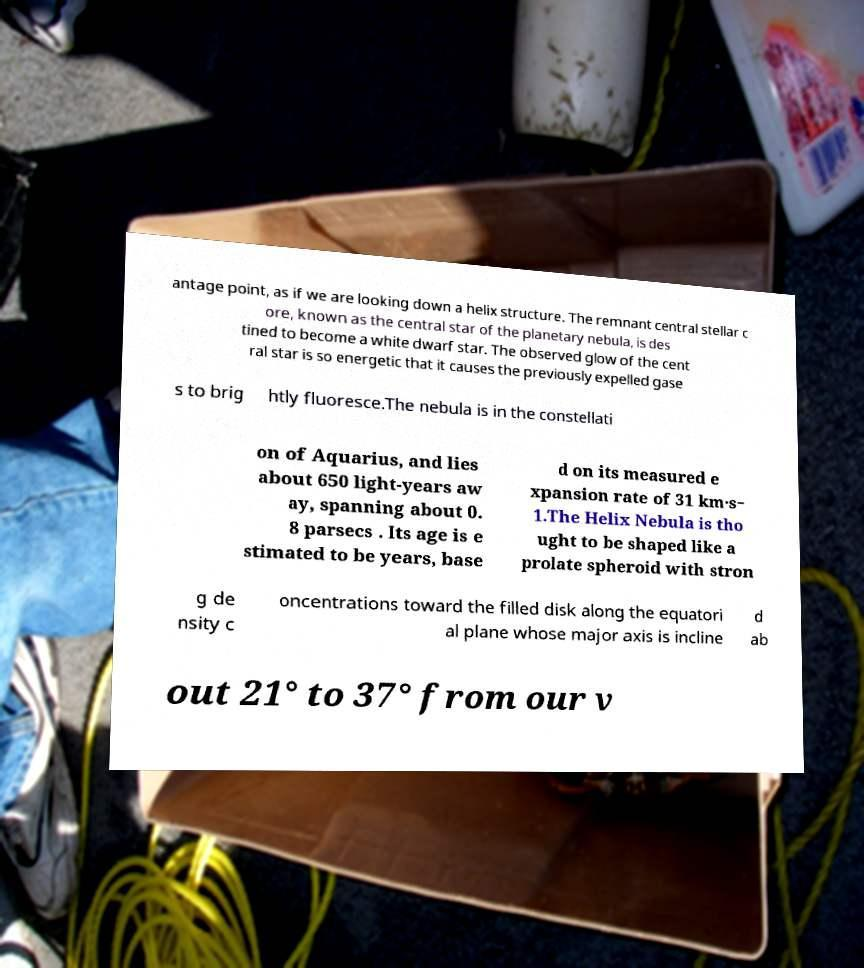Could you extract and type out the text from this image? antage point, as if we are looking down a helix structure. The remnant central stellar c ore, known as the central star of the planetary nebula, is des tined to become a white dwarf star. The observed glow of the cent ral star is so energetic that it causes the previously expelled gase s to brig htly fluoresce.The nebula is in the constellati on of Aquarius, and lies about 650 light-years aw ay, spanning about 0. 8 parsecs . Its age is e stimated to be years, base d on its measured e xpansion rate of 31 km·s− 1.The Helix Nebula is tho ught to be shaped like a prolate spheroid with stron g de nsity c oncentrations toward the filled disk along the equatori al plane whose major axis is incline d ab out 21° to 37° from our v 